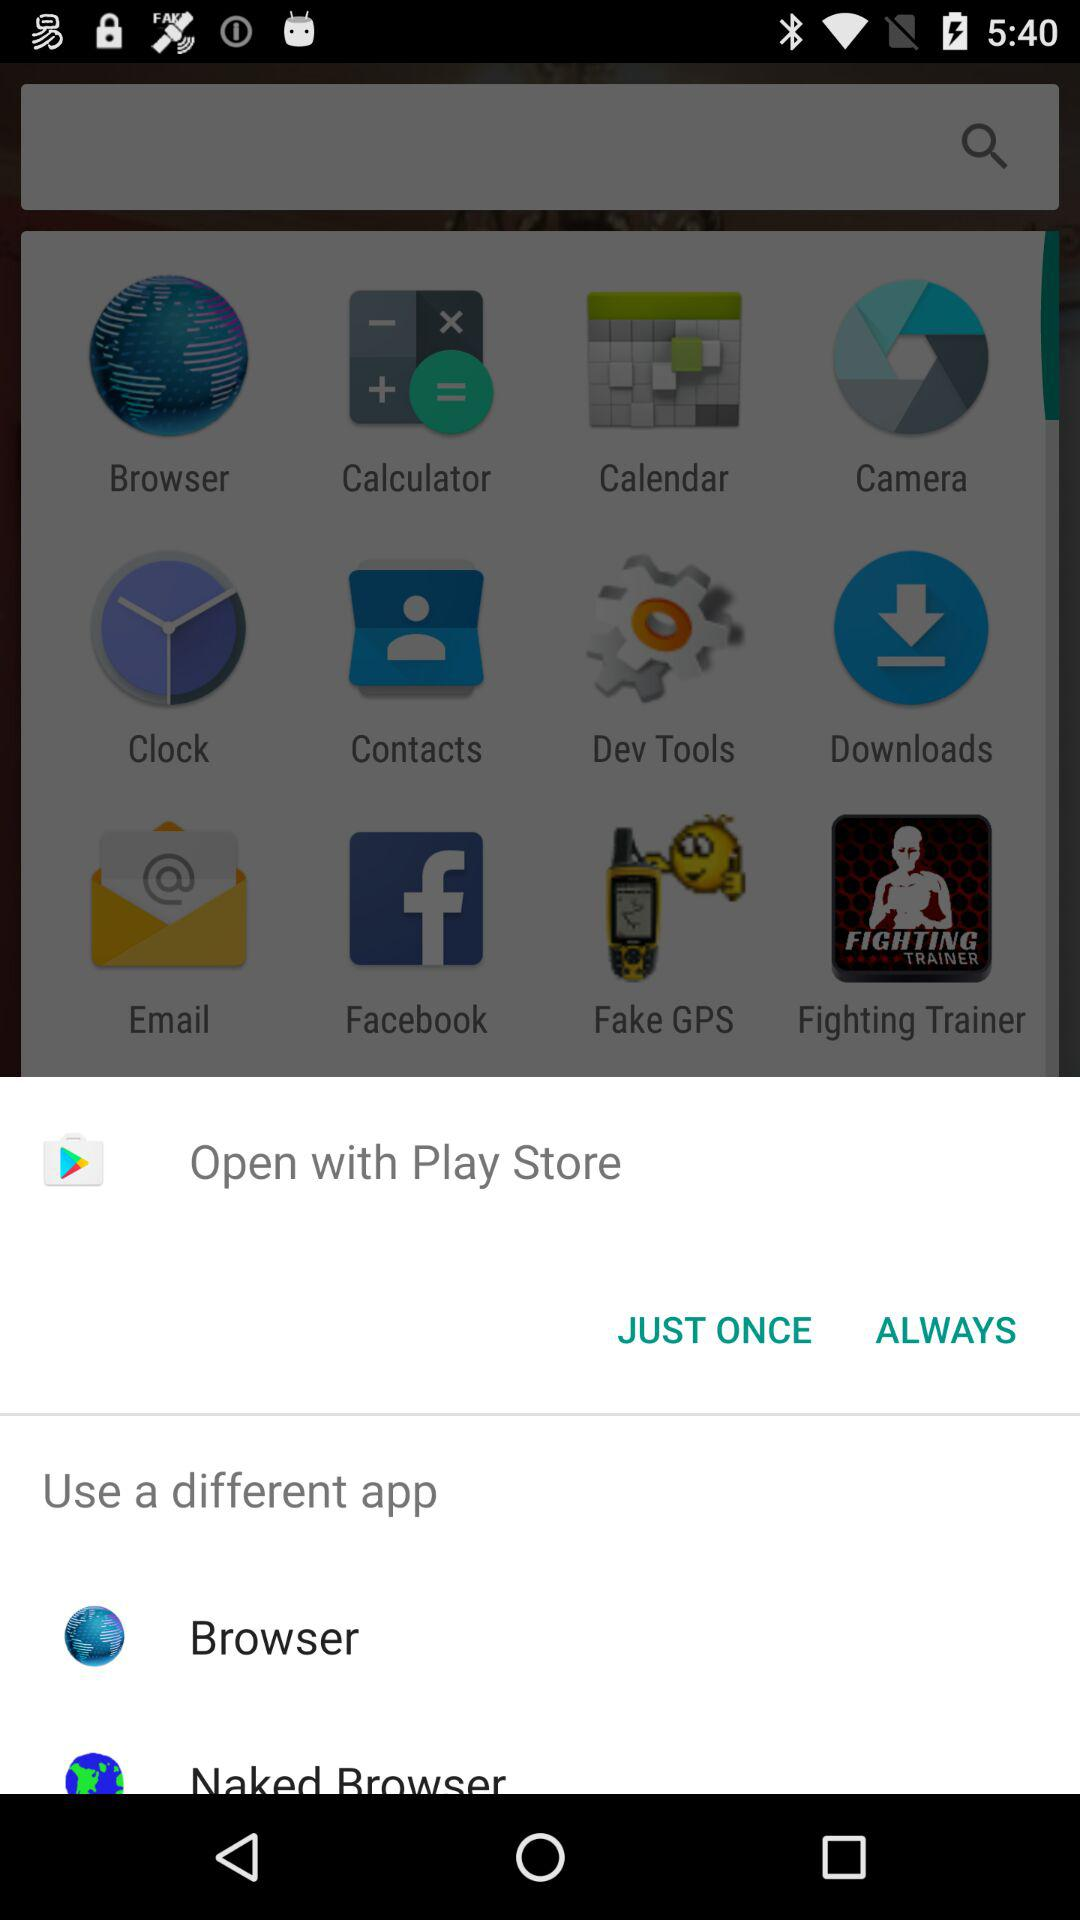Which are the different options to open? The different options to open are "Browser" and "Naked Browser". 